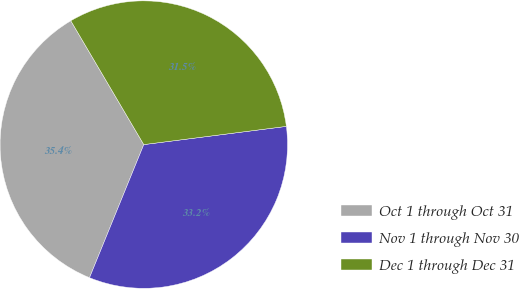Convert chart to OTSL. <chart><loc_0><loc_0><loc_500><loc_500><pie_chart><fcel>Oct 1 through Oct 31<fcel>Nov 1 through Nov 30<fcel>Dec 1 through Dec 31<nl><fcel>35.36%<fcel>33.18%<fcel>31.45%<nl></chart> 